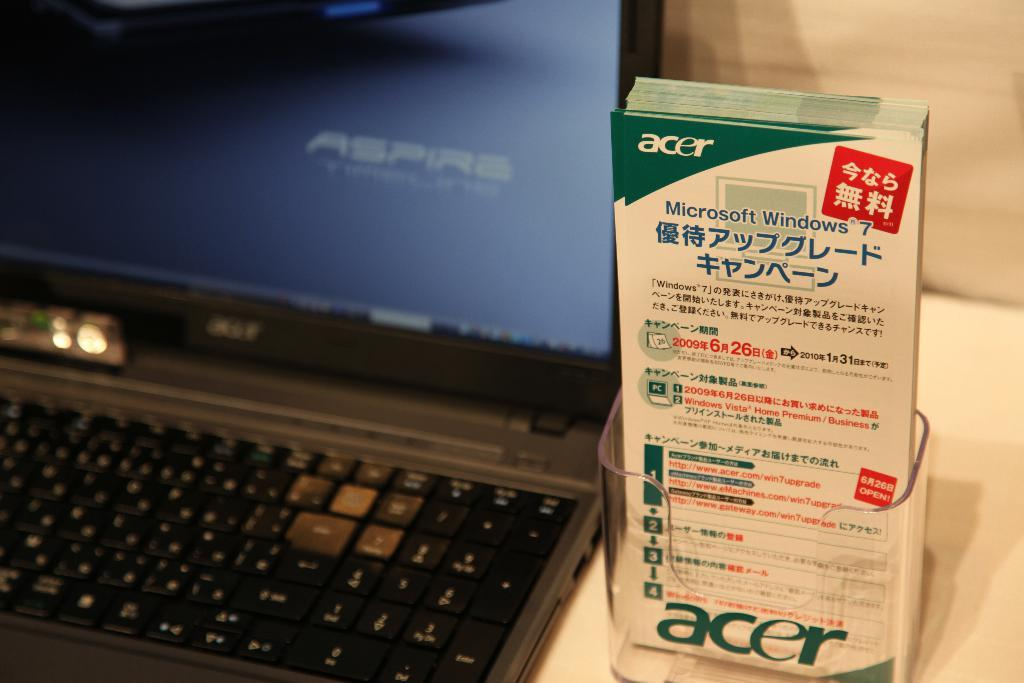<image>
Present a compact description of the photo's key features. A Acer box is sitting next to a Aspire computer. 